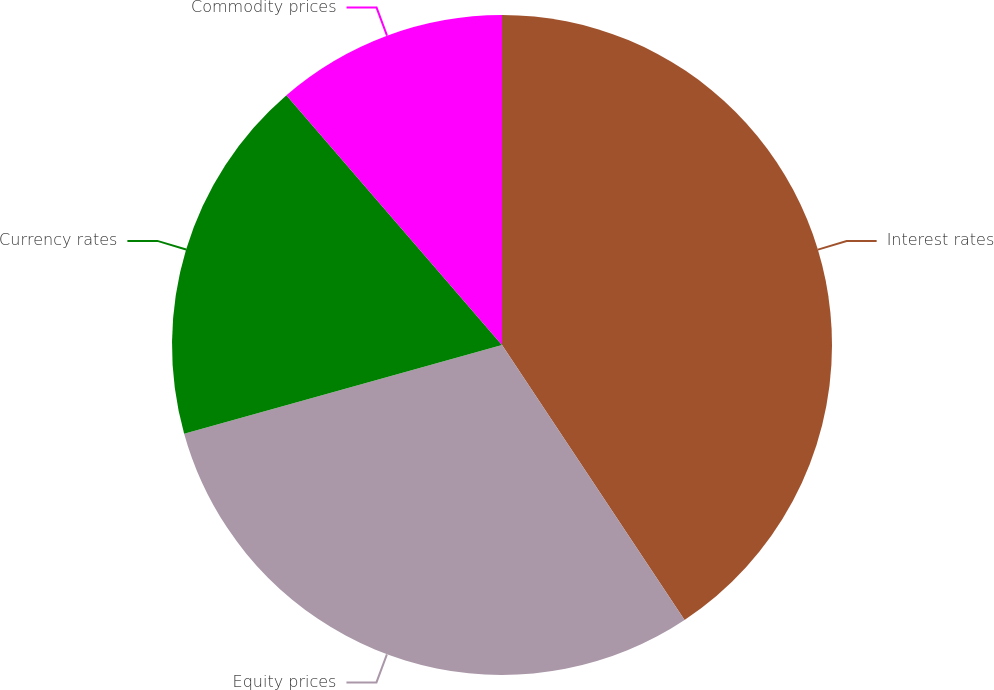Convert chart to OTSL. <chart><loc_0><loc_0><loc_500><loc_500><pie_chart><fcel>Interest rates<fcel>Equity prices<fcel>Currency rates<fcel>Commodity prices<nl><fcel>40.67%<fcel>30.0%<fcel>18.0%<fcel>11.33%<nl></chart> 